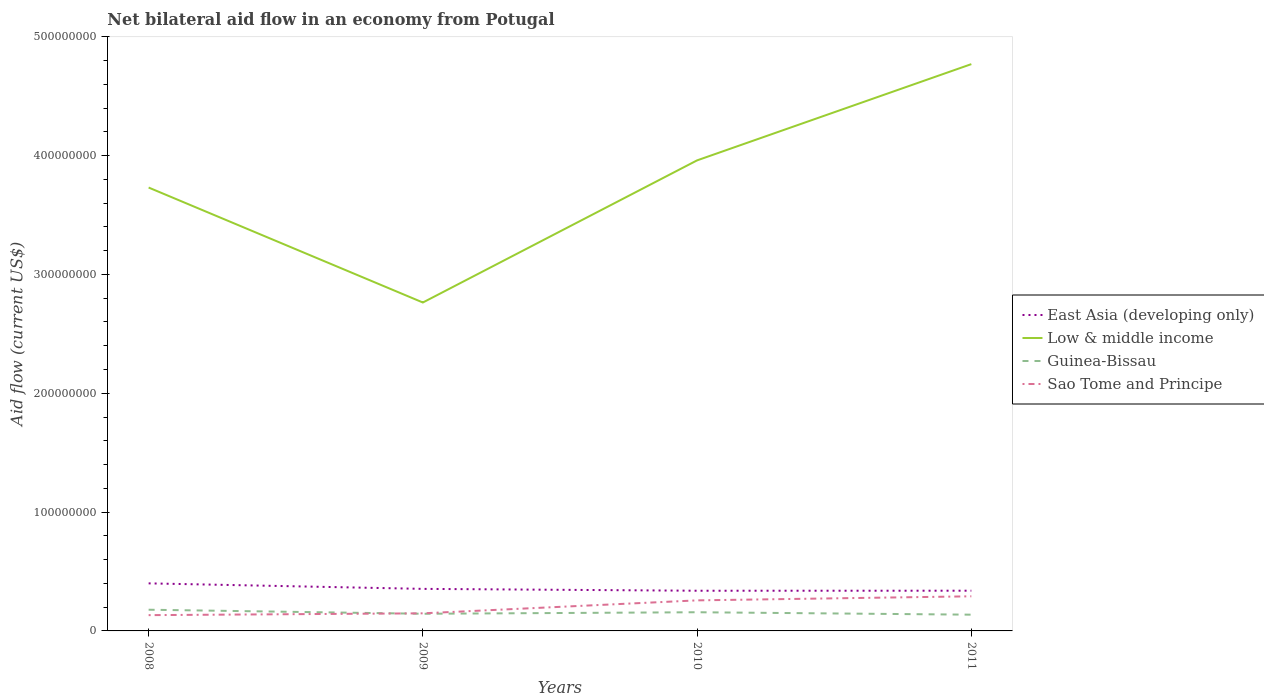Is the number of lines equal to the number of legend labels?
Your answer should be compact. Yes. Across all years, what is the maximum net bilateral aid flow in Sao Tome and Principe?
Give a very brief answer. 1.33e+07. What is the total net bilateral aid flow in Low & middle income in the graph?
Your answer should be compact. -2.29e+07. What is the difference between the highest and the second highest net bilateral aid flow in Low & middle income?
Offer a very short reply. 2.01e+08. Is the net bilateral aid flow in Guinea-Bissau strictly greater than the net bilateral aid flow in East Asia (developing only) over the years?
Give a very brief answer. Yes. How many years are there in the graph?
Your response must be concise. 4. What is the difference between two consecutive major ticks on the Y-axis?
Your response must be concise. 1.00e+08. Does the graph contain grids?
Your answer should be very brief. No. How are the legend labels stacked?
Ensure brevity in your answer.  Vertical. What is the title of the graph?
Make the answer very short. Net bilateral aid flow in an economy from Potugal. What is the label or title of the X-axis?
Your answer should be compact. Years. What is the label or title of the Y-axis?
Offer a terse response. Aid flow (current US$). What is the Aid flow (current US$) of East Asia (developing only) in 2008?
Your answer should be very brief. 4.00e+07. What is the Aid flow (current US$) in Low & middle income in 2008?
Your response must be concise. 3.73e+08. What is the Aid flow (current US$) in Guinea-Bissau in 2008?
Make the answer very short. 1.78e+07. What is the Aid flow (current US$) in Sao Tome and Principe in 2008?
Give a very brief answer. 1.33e+07. What is the Aid flow (current US$) in East Asia (developing only) in 2009?
Provide a succinct answer. 3.54e+07. What is the Aid flow (current US$) in Low & middle income in 2009?
Offer a very short reply. 2.76e+08. What is the Aid flow (current US$) of Guinea-Bissau in 2009?
Provide a short and direct response. 1.44e+07. What is the Aid flow (current US$) of Sao Tome and Principe in 2009?
Your answer should be very brief. 1.48e+07. What is the Aid flow (current US$) of East Asia (developing only) in 2010?
Provide a succinct answer. 3.38e+07. What is the Aid flow (current US$) of Low & middle income in 2010?
Your answer should be very brief. 3.96e+08. What is the Aid flow (current US$) in Guinea-Bissau in 2010?
Give a very brief answer. 1.57e+07. What is the Aid flow (current US$) in Sao Tome and Principe in 2010?
Your answer should be very brief. 2.57e+07. What is the Aid flow (current US$) of East Asia (developing only) in 2011?
Make the answer very short. 3.38e+07. What is the Aid flow (current US$) of Low & middle income in 2011?
Your answer should be compact. 4.77e+08. What is the Aid flow (current US$) of Guinea-Bissau in 2011?
Your answer should be compact. 1.37e+07. What is the Aid flow (current US$) of Sao Tome and Principe in 2011?
Offer a very short reply. 2.91e+07. Across all years, what is the maximum Aid flow (current US$) in East Asia (developing only)?
Provide a short and direct response. 4.00e+07. Across all years, what is the maximum Aid flow (current US$) of Low & middle income?
Provide a short and direct response. 4.77e+08. Across all years, what is the maximum Aid flow (current US$) of Guinea-Bissau?
Your answer should be very brief. 1.78e+07. Across all years, what is the maximum Aid flow (current US$) of Sao Tome and Principe?
Provide a succinct answer. 2.91e+07. Across all years, what is the minimum Aid flow (current US$) in East Asia (developing only)?
Keep it short and to the point. 3.38e+07. Across all years, what is the minimum Aid flow (current US$) of Low & middle income?
Your answer should be compact. 2.76e+08. Across all years, what is the minimum Aid flow (current US$) in Guinea-Bissau?
Offer a very short reply. 1.37e+07. Across all years, what is the minimum Aid flow (current US$) in Sao Tome and Principe?
Ensure brevity in your answer.  1.33e+07. What is the total Aid flow (current US$) of East Asia (developing only) in the graph?
Make the answer very short. 1.43e+08. What is the total Aid flow (current US$) in Low & middle income in the graph?
Provide a short and direct response. 1.52e+09. What is the total Aid flow (current US$) of Guinea-Bissau in the graph?
Provide a short and direct response. 6.17e+07. What is the total Aid flow (current US$) of Sao Tome and Principe in the graph?
Make the answer very short. 8.29e+07. What is the difference between the Aid flow (current US$) of East Asia (developing only) in 2008 and that in 2009?
Provide a short and direct response. 4.64e+06. What is the difference between the Aid flow (current US$) of Low & middle income in 2008 and that in 2009?
Your answer should be compact. 9.67e+07. What is the difference between the Aid flow (current US$) of Guinea-Bissau in 2008 and that in 2009?
Offer a very short reply. 3.41e+06. What is the difference between the Aid flow (current US$) of Sao Tome and Principe in 2008 and that in 2009?
Offer a very short reply. -1.53e+06. What is the difference between the Aid flow (current US$) in East Asia (developing only) in 2008 and that in 2010?
Your answer should be very brief. 6.20e+06. What is the difference between the Aid flow (current US$) in Low & middle income in 2008 and that in 2010?
Ensure brevity in your answer.  -2.29e+07. What is the difference between the Aid flow (current US$) of Guinea-Bissau in 2008 and that in 2010?
Your answer should be very brief. 2.12e+06. What is the difference between the Aid flow (current US$) of Sao Tome and Principe in 2008 and that in 2010?
Ensure brevity in your answer.  -1.24e+07. What is the difference between the Aid flow (current US$) of East Asia (developing only) in 2008 and that in 2011?
Make the answer very short. 6.18e+06. What is the difference between the Aid flow (current US$) of Low & middle income in 2008 and that in 2011?
Provide a succinct answer. -1.04e+08. What is the difference between the Aid flow (current US$) in Guinea-Bissau in 2008 and that in 2011?
Make the answer very short. 4.17e+06. What is the difference between the Aid flow (current US$) of Sao Tome and Principe in 2008 and that in 2011?
Provide a succinct answer. -1.58e+07. What is the difference between the Aid flow (current US$) in East Asia (developing only) in 2009 and that in 2010?
Provide a succinct answer. 1.56e+06. What is the difference between the Aid flow (current US$) of Low & middle income in 2009 and that in 2010?
Provide a succinct answer. -1.20e+08. What is the difference between the Aid flow (current US$) of Guinea-Bissau in 2009 and that in 2010?
Provide a short and direct response. -1.29e+06. What is the difference between the Aid flow (current US$) of Sao Tome and Principe in 2009 and that in 2010?
Provide a succinct answer. -1.09e+07. What is the difference between the Aid flow (current US$) of East Asia (developing only) in 2009 and that in 2011?
Make the answer very short. 1.54e+06. What is the difference between the Aid flow (current US$) of Low & middle income in 2009 and that in 2011?
Provide a succinct answer. -2.01e+08. What is the difference between the Aid flow (current US$) of Guinea-Bissau in 2009 and that in 2011?
Provide a succinct answer. 7.60e+05. What is the difference between the Aid flow (current US$) in Sao Tome and Principe in 2009 and that in 2011?
Offer a terse response. -1.43e+07. What is the difference between the Aid flow (current US$) of East Asia (developing only) in 2010 and that in 2011?
Keep it short and to the point. -2.00e+04. What is the difference between the Aid flow (current US$) of Low & middle income in 2010 and that in 2011?
Ensure brevity in your answer.  -8.10e+07. What is the difference between the Aid flow (current US$) in Guinea-Bissau in 2010 and that in 2011?
Offer a very short reply. 2.05e+06. What is the difference between the Aid flow (current US$) in Sao Tome and Principe in 2010 and that in 2011?
Provide a short and direct response. -3.42e+06. What is the difference between the Aid flow (current US$) in East Asia (developing only) in 2008 and the Aid flow (current US$) in Low & middle income in 2009?
Offer a very short reply. -2.36e+08. What is the difference between the Aid flow (current US$) of East Asia (developing only) in 2008 and the Aid flow (current US$) of Guinea-Bissau in 2009?
Offer a terse response. 2.56e+07. What is the difference between the Aid flow (current US$) of East Asia (developing only) in 2008 and the Aid flow (current US$) of Sao Tome and Principe in 2009?
Keep it short and to the point. 2.52e+07. What is the difference between the Aid flow (current US$) of Low & middle income in 2008 and the Aid flow (current US$) of Guinea-Bissau in 2009?
Provide a succinct answer. 3.59e+08. What is the difference between the Aid flow (current US$) of Low & middle income in 2008 and the Aid flow (current US$) of Sao Tome and Principe in 2009?
Offer a very short reply. 3.58e+08. What is the difference between the Aid flow (current US$) of Guinea-Bissau in 2008 and the Aid flow (current US$) of Sao Tome and Principe in 2009?
Your response must be concise. 3.03e+06. What is the difference between the Aid flow (current US$) in East Asia (developing only) in 2008 and the Aid flow (current US$) in Low & middle income in 2010?
Your answer should be very brief. -3.56e+08. What is the difference between the Aid flow (current US$) of East Asia (developing only) in 2008 and the Aid flow (current US$) of Guinea-Bissau in 2010?
Make the answer very short. 2.43e+07. What is the difference between the Aid flow (current US$) of East Asia (developing only) in 2008 and the Aid flow (current US$) of Sao Tome and Principe in 2010?
Your response must be concise. 1.43e+07. What is the difference between the Aid flow (current US$) of Low & middle income in 2008 and the Aid flow (current US$) of Guinea-Bissau in 2010?
Your answer should be compact. 3.57e+08. What is the difference between the Aid flow (current US$) in Low & middle income in 2008 and the Aid flow (current US$) in Sao Tome and Principe in 2010?
Your answer should be very brief. 3.47e+08. What is the difference between the Aid flow (current US$) of Guinea-Bissau in 2008 and the Aid flow (current US$) of Sao Tome and Principe in 2010?
Offer a very short reply. -7.87e+06. What is the difference between the Aid flow (current US$) in East Asia (developing only) in 2008 and the Aid flow (current US$) in Low & middle income in 2011?
Your answer should be very brief. -4.37e+08. What is the difference between the Aid flow (current US$) in East Asia (developing only) in 2008 and the Aid flow (current US$) in Guinea-Bissau in 2011?
Your response must be concise. 2.64e+07. What is the difference between the Aid flow (current US$) in East Asia (developing only) in 2008 and the Aid flow (current US$) in Sao Tome and Principe in 2011?
Keep it short and to the point. 1.09e+07. What is the difference between the Aid flow (current US$) of Low & middle income in 2008 and the Aid flow (current US$) of Guinea-Bissau in 2011?
Offer a very short reply. 3.59e+08. What is the difference between the Aid flow (current US$) of Low & middle income in 2008 and the Aid flow (current US$) of Sao Tome and Principe in 2011?
Offer a very short reply. 3.44e+08. What is the difference between the Aid flow (current US$) of Guinea-Bissau in 2008 and the Aid flow (current US$) of Sao Tome and Principe in 2011?
Provide a short and direct response. -1.13e+07. What is the difference between the Aid flow (current US$) in East Asia (developing only) in 2009 and the Aid flow (current US$) in Low & middle income in 2010?
Make the answer very short. -3.61e+08. What is the difference between the Aid flow (current US$) in East Asia (developing only) in 2009 and the Aid flow (current US$) in Guinea-Bissau in 2010?
Offer a very short reply. 1.97e+07. What is the difference between the Aid flow (current US$) in East Asia (developing only) in 2009 and the Aid flow (current US$) in Sao Tome and Principe in 2010?
Your response must be concise. 9.67e+06. What is the difference between the Aid flow (current US$) of Low & middle income in 2009 and the Aid flow (current US$) of Guinea-Bissau in 2010?
Your answer should be compact. 2.61e+08. What is the difference between the Aid flow (current US$) in Low & middle income in 2009 and the Aid flow (current US$) in Sao Tome and Principe in 2010?
Ensure brevity in your answer.  2.51e+08. What is the difference between the Aid flow (current US$) of Guinea-Bissau in 2009 and the Aid flow (current US$) of Sao Tome and Principe in 2010?
Make the answer very short. -1.13e+07. What is the difference between the Aid flow (current US$) of East Asia (developing only) in 2009 and the Aid flow (current US$) of Low & middle income in 2011?
Your answer should be compact. -4.42e+08. What is the difference between the Aid flow (current US$) of East Asia (developing only) in 2009 and the Aid flow (current US$) of Guinea-Bissau in 2011?
Your response must be concise. 2.17e+07. What is the difference between the Aid flow (current US$) in East Asia (developing only) in 2009 and the Aid flow (current US$) in Sao Tome and Principe in 2011?
Provide a short and direct response. 6.25e+06. What is the difference between the Aid flow (current US$) in Low & middle income in 2009 and the Aid flow (current US$) in Guinea-Bissau in 2011?
Provide a short and direct response. 2.63e+08. What is the difference between the Aid flow (current US$) in Low & middle income in 2009 and the Aid flow (current US$) in Sao Tome and Principe in 2011?
Offer a terse response. 2.47e+08. What is the difference between the Aid flow (current US$) in Guinea-Bissau in 2009 and the Aid flow (current US$) in Sao Tome and Principe in 2011?
Keep it short and to the point. -1.47e+07. What is the difference between the Aid flow (current US$) in East Asia (developing only) in 2010 and the Aid flow (current US$) in Low & middle income in 2011?
Ensure brevity in your answer.  -4.43e+08. What is the difference between the Aid flow (current US$) of East Asia (developing only) in 2010 and the Aid flow (current US$) of Guinea-Bissau in 2011?
Your response must be concise. 2.02e+07. What is the difference between the Aid flow (current US$) of East Asia (developing only) in 2010 and the Aid flow (current US$) of Sao Tome and Principe in 2011?
Provide a short and direct response. 4.69e+06. What is the difference between the Aid flow (current US$) of Low & middle income in 2010 and the Aid flow (current US$) of Guinea-Bissau in 2011?
Give a very brief answer. 3.82e+08. What is the difference between the Aid flow (current US$) of Low & middle income in 2010 and the Aid flow (current US$) of Sao Tome and Principe in 2011?
Provide a short and direct response. 3.67e+08. What is the difference between the Aid flow (current US$) of Guinea-Bissau in 2010 and the Aid flow (current US$) of Sao Tome and Principe in 2011?
Your answer should be compact. -1.34e+07. What is the average Aid flow (current US$) of East Asia (developing only) per year?
Offer a terse response. 3.58e+07. What is the average Aid flow (current US$) in Low & middle income per year?
Your answer should be compact. 3.81e+08. What is the average Aid flow (current US$) of Guinea-Bissau per year?
Make the answer very short. 1.54e+07. What is the average Aid flow (current US$) of Sao Tome and Principe per year?
Provide a short and direct response. 2.07e+07. In the year 2008, what is the difference between the Aid flow (current US$) in East Asia (developing only) and Aid flow (current US$) in Low & middle income?
Make the answer very short. -3.33e+08. In the year 2008, what is the difference between the Aid flow (current US$) of East Asia (developing only) and Aid flow (current US$) of Guinea-Bissau?
Give a very brief answer. 2.22e+07. In the year 2008, what is the difference between the Aid flow (current US$) in East Asia (developing only) and Aid flow (current US$) in Sao Tome and Principe?
Offer a terse response. 2.67e+07. In the year 2008, what is the difference between the Aid flow (current US$) of Low & middle income and Aid flow (current US$) of Guinea-Bissau?
Your response must be concise. 3.55e+08. In the year 2008, what is the difference between the Aid flow (current US$) in Low & middle income and Aid flow (current US$) in Sao Tome and Principe?
Ensure brevity in your answer.  3.60e+08. In the year 2008, what is the difference between the Aid flow (current US$) of Guinea-Bissau and Aid flow (current US$) of Sao Tome and Principe?
Give a very brief answer. 4.56e+06. In the year 2009, what is the difference between the Aid flow (current US$) of East Asia (developing only) and Aid flow (current US$) of Low & middle income?
Offer a terse response. -2.41e+08. In the year 2009, what is the difference between the Aid flow (current US$) of East Asia (developing only) and Aid flow (current US$) of Guinea-Bissau?
Offer a very short reply. 2.10e+07. In the year 2009, what is the difference between the Aid flow (current US$) of East Asia (developing only) and Aid flow (current US$) of Sao Tome and Principe?
Offer a very short reply. 2.06e+07. In the year 2009, what is the difference between the Aid flow (current US$) in Low & middle income and Aid flow (current US$) in Guinea-Bissau?
Provide a succinct answer. 2.62e+08. In the year 2009, what is the difference between the Aid flow (current US$) in Low & middle income and Aid flow (current US$) in Sao Tome and Principe?
Give a very brief answer. 2.62e+08. In the year 2009, what is the difference between the Aid flow (current US$) of Guinea-Bissau and Aid flow (current US$) of Sao Tome and Principe?
Your response must be concise. -3.80e+05. In the year 2010, what is the difference between the Aid flow (current US$) of East Asia (developing only) and Aid flow (current US$) of Low & middle income?
Keep it short and to the point. -3.62e+08. In the year 2010, what is the difference between the Aid flow (current US$) of East Asia (developing only) and Aid flow (current US$) of Guinea-Bissau?
Your response must be concise. 1.81e+07. In the year 2010, what is the difference between the Aid flow (current US$) in East Asia (developing only) and Aid flow (current US$) in Sao Tome and Principe?
Offer a terse response. 8.11e+06. In the year 2010, what is the difference between the Aid flow (current US$) in Low & middle income and Aid flow (current US$) in Guinea-Bissau?
Your answer should be very brief. 3.80e+08. In the year 2010, what is the difference between the Aid flow (current US$) of Low & middle income and Aid flow (current US$) of Sao Tome and Principe?
Keep it short and to the point. 3.70e+08. In the year 2010, what is the difference between the Aid flow (current US$) in Guinea-Bissau and Aid flow (current US$) in Sao Tome and Principe?
Offer a very short reply. -9.99e+06. In the year 2011, what is the difference between the Aid flow (current US$) in East Asia (developing only) and Aid flow (current US$) in Low & middle income?
Provide a short and direct response. -4.43e+08. In the year 2011, what is the difference between the Aid flow (current US$) of East Asia (developing only) and Aid flow (current US$) of Guinea-Bissau?
Offer a very short reply. 2.02e+07. In the year 2011, what is the difference between the Aid flow (current US$) in East Asia (developing only) and Aid flow (current US$) in Sao Tome and Principe?
Keep it short and to the point. 4.71e+06. In the year 2011, what is the difference between the Aid flow (current US$) of Low & middle income and Aid flow (current US$) of Guinea-Bissau?
Your response must be concise. 4.63e+08. In the year 2011, what is the difference between the Aid flow (current US$) of Low & middle income and Aid flow (current US$) of Sao Tome and Principe?
Your answer should be very brief. 4.48e+08. In the year 2011, what is the difference between the Aid flow (current US$) in Guinea-Bissau and Aid flow (current US$) in Sao Tome and Principe?
Ensure brevity in your answer.  -1.55e+07. What is the ratio of the Aid flow (current US$) in East Asia (developing only) in 2008 to that in 2009?
Keep it short and to the point. 1.13. What is the ratio of the Aid flow (current US$) of Low & middle income in 2008 to that in 2009?
Provide a short and direct response. 1.35. What is the ratio of the Aid flow (current US$) in Guinea-Bissau in 2008 to that in 2009?
Give a very brief answer. 1.24. What is the ratio of the Aid flow (current US$) of Sao Tome and Principe in 2008 to that in 2009?
Offer a terse response. 0.9. What is the ratio of the Aid flow (current US$) of East Asia (developing only) in 2008 to that in 2010?
Keep it short and to the point. 1.18. What is the ratio of the Aid flow (current US$) of Low & middle income in 2008 to that in 2010?
Provide a short and direct response. 0.94. What is the ratio of the Aid flow (current US$) of Guinea-Bissau in 2008 to that in 2010?
Provide a short and direct response. 1.13. What is the ratio of the Aid flow (current US$) in Sao Tome and Principe in 2008 to that in 2010?
Provide a succinct answer. 0.52. What is the ratio of the Aid flow (current US$) in East Asia (developing only) in 2008 to that in 2011?
Your response must be concise. 1.18. What is the ratio of the Aid flow (current US$) of Low & middle income in 2008 to that in 2011?
Ensure brevity in your answer.  0.78. What is the ratio of the Aid flow (current US$) in Guinea-Bissau in 2008 to that in 2011?
Give a very brief answer. 1.3. What is the ratio of the Aid flow (current US$) of Sao Tome and Principe in 2008 to that in 2011?
Ensure brevity in your answer.  0.46. What is the ratio of the Aid flow (current US$) in East Asia (developing only) in 2009 to that in 2010?
Keep it short and to the point. 1.05. What is the ratio of the Aid flow (current US$) in Low & middle income in 2009 to that in 2010?
Offer a very short reply. 0.7. What is the ratio of the Aid flow (current US$) of Guinea-Bissau in 2009 to that in 2010?
Provide a succinct answer. 0.92. What is the ratio of the Aid flow (current US$) in Sao Tome and Principe in 2009 to that in 2010?
Make the answer very short. 0.58. What is the ratio of the Aid flow (current US$) in East Asia (developing only) in 2009 to that in 2011?
Offer a terse response. 1.05. What is the ratio of the Aid flow (current US$) of Low & middle income in 2009 to that in 2011?
Make the answer very short. 0.58. What is the ratio of the Aid flow (current US$) of Guinea-Bissau in 2009 to that in 2011?
Your answer should be compact. 1.06. What is the ratio of the Aid flow (current US$) of Sao Tome and Principe in 2009 to that in 2011?
Provide a short and direct response. 0.51. What is the ratio of the Aid flow (current US$) in Low & middle income in 2010 to that in 2011?
Keep it short and to the point. 0.83. What is the ratio of the Aid flow (current US$) in Guinea-Bissau in 2010 to that in 2011?
Offer a terse response. 1.15. What is the ratio of the Aid flow (current US$) in Sao Tome and Principe in 2010 to that in 2011?
Your response must be concise. 0.88. What is the difference between the highest and the second highest Aid flow (current US$) in East Asia (developing only)?
Your answer should be compact. 4.64e+06. What is the difference between the highest and the second highest Aid flow (current US$) in Low & middle income?
Your answer should be compact. 8.10e+07. What is the difference between the highest and the second highest Aid flow (current US$) of Guinea-Bissau?
Provide a succinct answer. 2.12e+06. What is the difference between the highest and the second highest Aid flow (current US$) of Sao Tome and Principe?
Give a very brief answer. 3.42e+06. What is the difference between the highest and the lowest Aid flow (current US$) of East Asia (developing only)?
Provide a short and direct response. 6.20e+06. What is the difference between the highest and the lowest Aid flow (current US$) in Low & middle income?
Give a very brief answer. 2.01e+08. What is the difference between the highest and the lowest Aid flow (current US$) of Guinea-Bissau?
Offer a terse response. 4.17e+06. What is the difference between the highest and the lowest Aid flow (current US$) of Sao Tome and Principe?
Provide a short and direct response. 1.58e+07. 